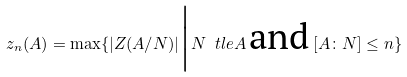<formula> <loc_0><loc_0><loc_500><loc_500>z _ { n } ( A ) = \max \{ | Z ( A / N ) | \Big | N \ t l e A \, \text {and} \, [ A \colon N ] \leq n \}</formula> 